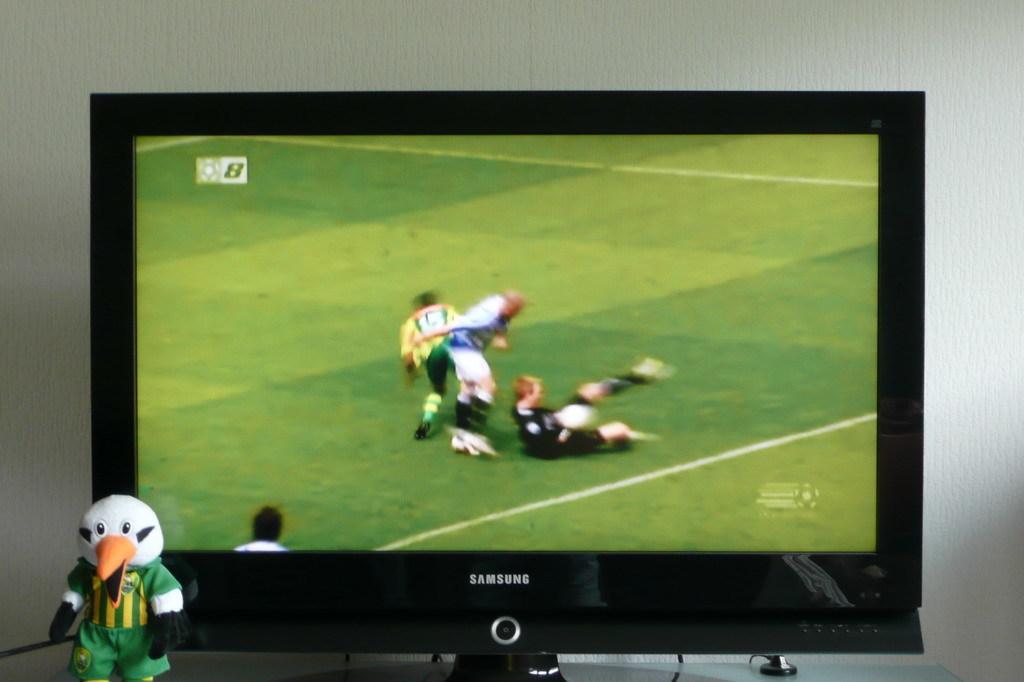What is the brand of this tv?
Make the answer very short. Samsung. What number is shown on the screen?
Provide a short and direct response. 8. 